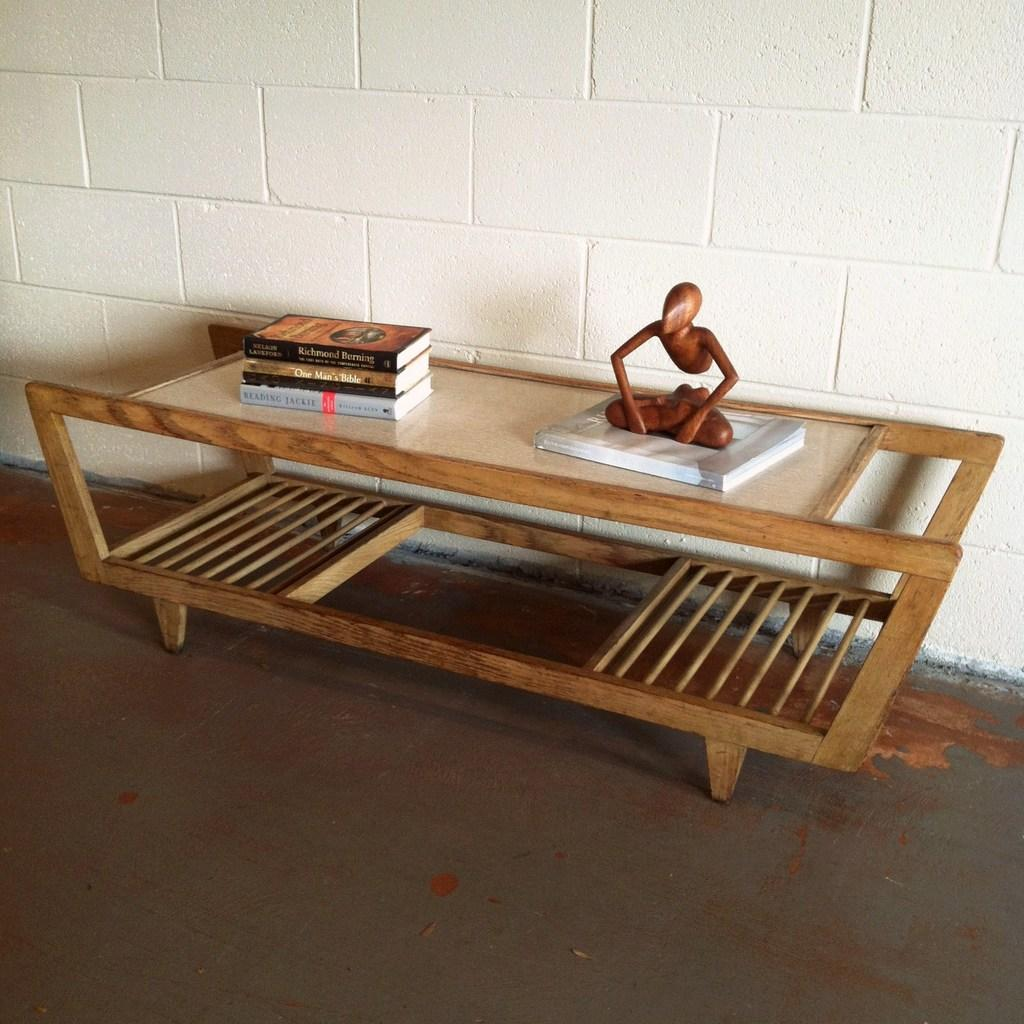What type of furniture is present in the image? There is a table in the image. What items are placed on the table? There are books on the table. What type of object is not related to the table or books? There is a toy in the image. How many birds can be seen on the desk in the image? There is no desk present in the image, and no birds are visible. 